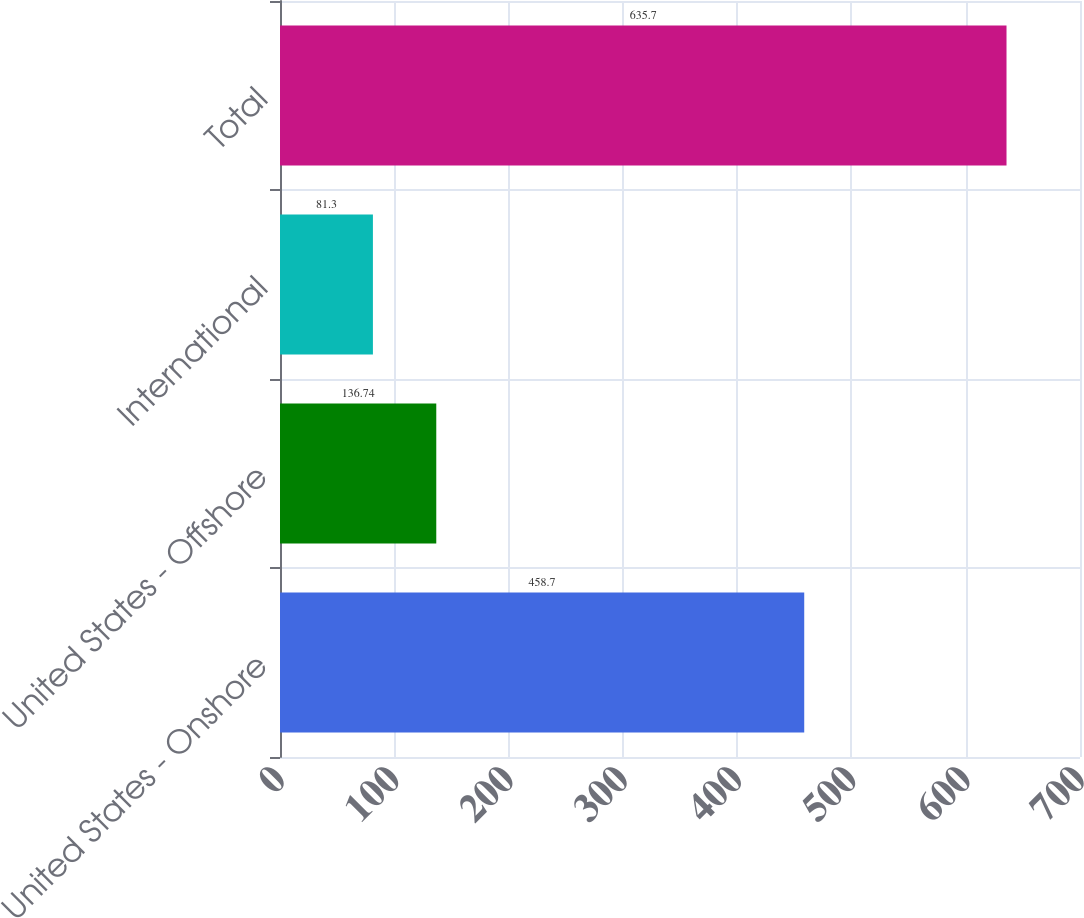<chart> <loc_0><loc_0><loc_500><loc_500><bar_chart><fcel>United States - Onshore<fcel>United States - Offshore<fcel>International<fcel>Total<nl><fcel>458.7<fcel>136.74<fcel>81.3<fcel>635.7<nl></chart> 